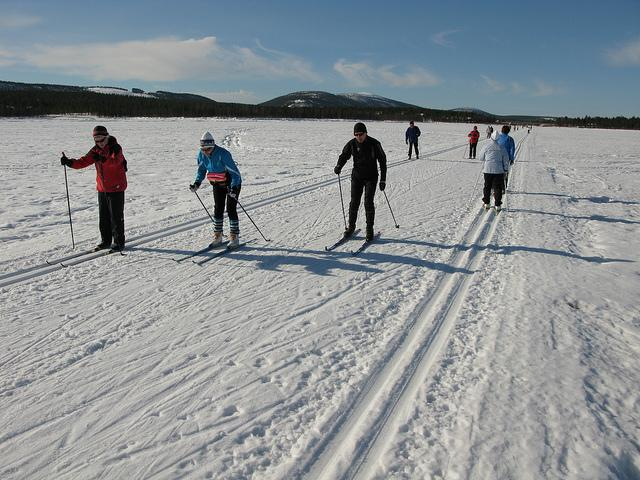What is the location of the sun in the image?

Choices:
A) right
B) front
C) back
D) left left 